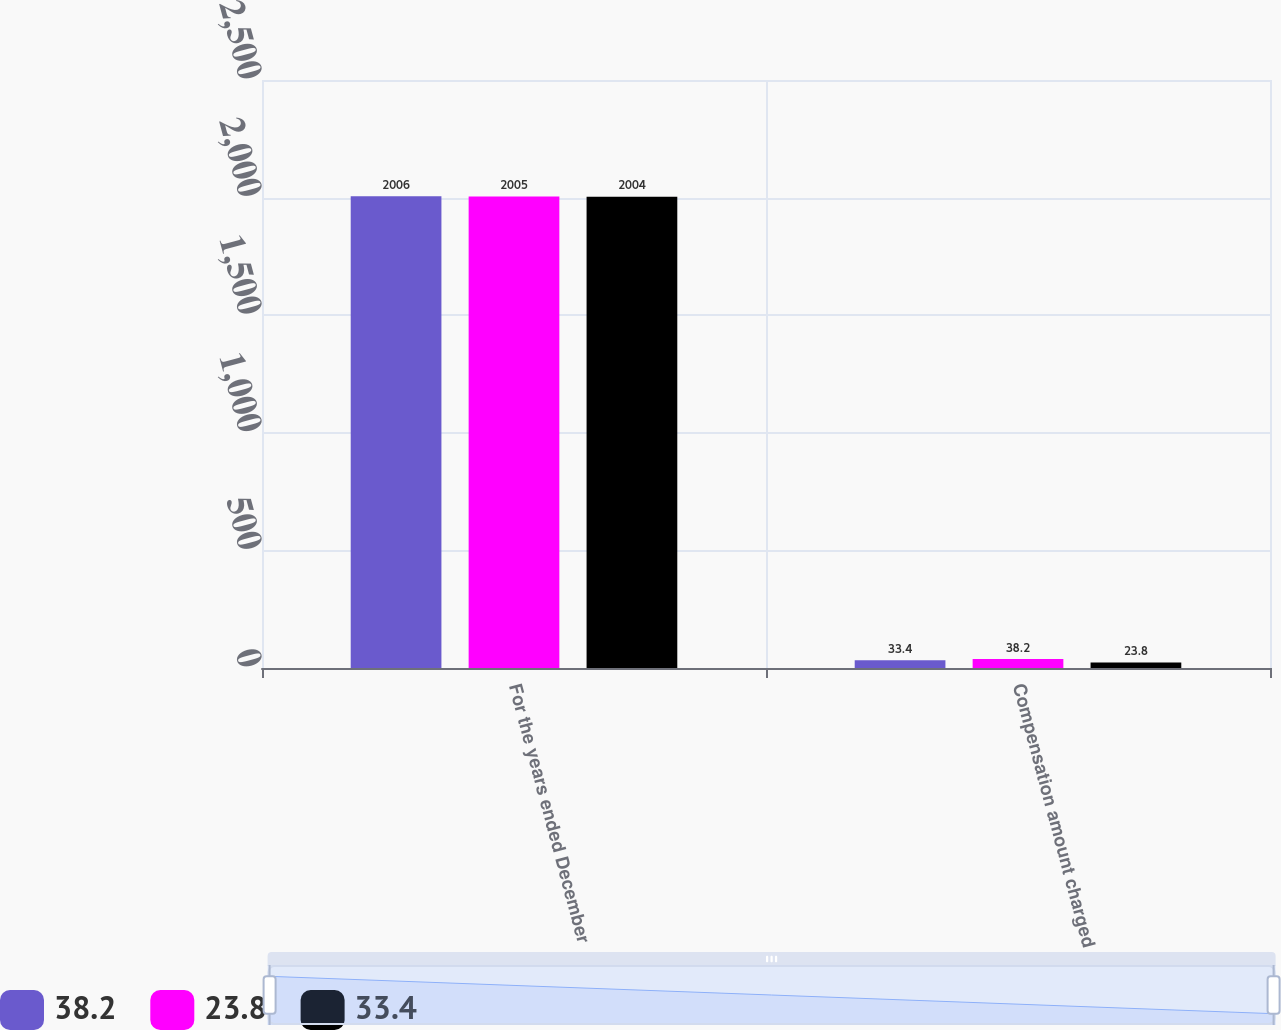<chart> <loc_0><loc_0><loc_500><loc_500><stacked_bar_chart><ecel><fcel>For the years ended December<fcel>Compensation amount charged<nl><fcel>38.2<fcel>2006<fcel>33.4<nl><fcel>23.8<fcel>2005<fcel>38.2<nl><fcel>33.4<fcel>2004<fcel>23.8<nl></chart> 